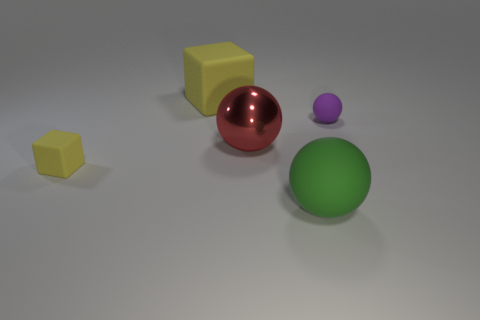Add 5 purple rubber objects. How many objects exist? 10 Subtract all large red balls. How many balls are left? 2 Subtract all green spheres. How many spheres are left? 2 Subtract 1 cubes. How many cubes are left? 1 Subtract all blocks. How many objects are left? 3 Subtract all small green matte balls. Subtract all rubber balls. How many objects are left? 3 Add 5 small matte balls. How many small matte balls are left? 6 Add 5 blocks. How many blocks exist? 7 Subtract 0 gray cubes. How many objects are left? 5 Subtract all red blocks. Subtract all purple balls. How many blocks are left? 2 